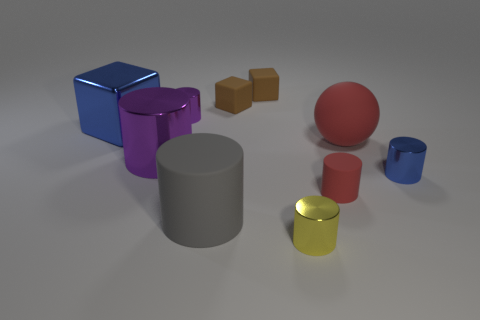Is there any other thing that has the same color as the small matte cylinder?
Your answer should be compact. Yes. What material is the large thing that is in front of the tiny cylinder right of the tiny rubber object in front of the red ball?
Ensure brevity in your answer.  Rubber. How many rubber things are either tiny cylinders or blue objects?
Ensure brevity in your answer.  1. How many blue things are metallic cylinders or rubber spheres?
Your response must be concise. 1. Does the small cylinder behind the large blue metal object have the same color as the big matte cylinder?
Make the answer very short. No. Is the material of the tiny blue cylinder the same as the big blue thing?
Make the answer very short. Yes. Is the number of blue cylinders left of the blue cylinder the same as the number of objects behind the large gray rubber cylinder?
Keep it short and to the point. No. What material is the small red object that is the same shape as the large purple shiny thing?
Make the answer very short. Rubber. What shape is the small red object that is in front of the big purple thing that is in front of the small purple metal object that is behind the metallic block?
Your answer should be very brief. Cylinder. Are there more cylinders that are behind the large purple shiny cylinder than tiny yellow cylinders?
Offer a very short reply. No. 